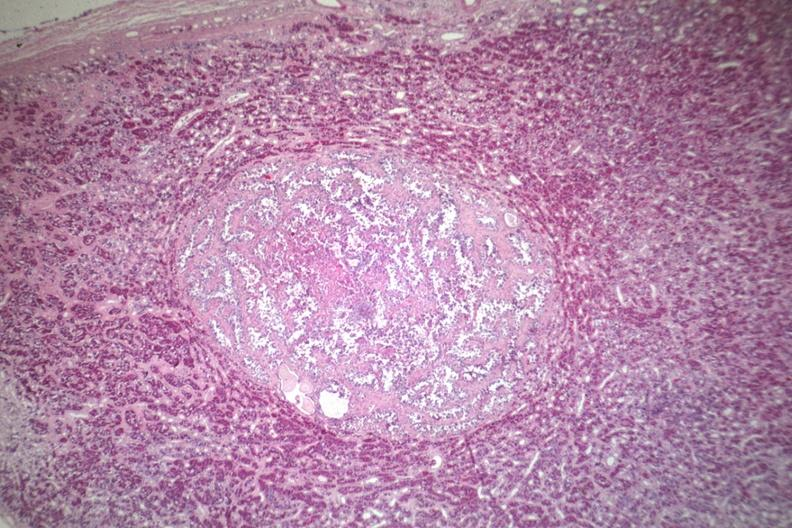how does well circumscribed papillary lesion see for mag?
Answer the question using a single word or phrase. High 